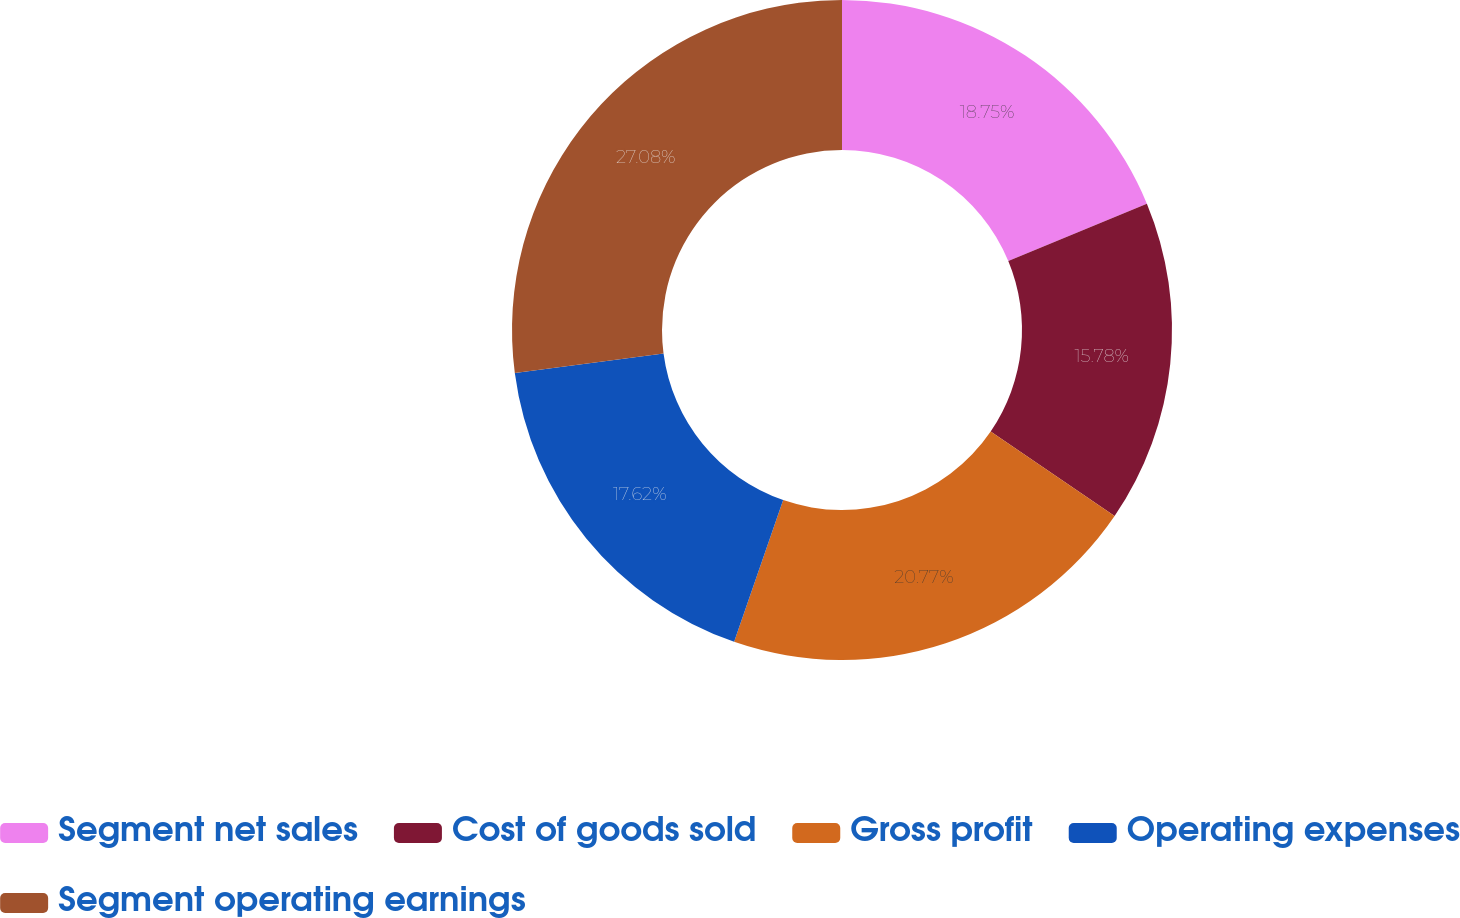Convert chart. <chart><loc_0><loc_0><loc_500><loc_500><pie_chart><fcel>Segment net sales<fcel>Cost of goods sold<fcel>Gross profit<fcel>Operating expenses<fcel>Segment operating earnings<nl><fcel>18.75%<fcel>15.78%<fcel>20.77%<fcel>17.62%<fcel>27.08%<nl></chart> 